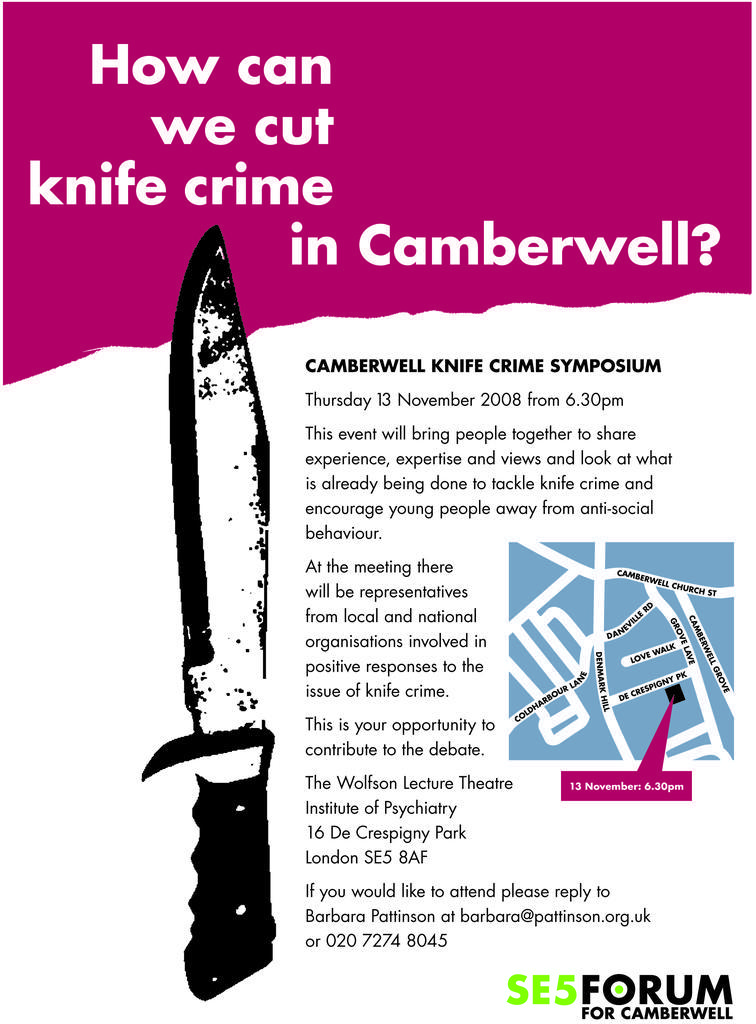In one or two sentences, can you explain what this image depicts? Here we can see a poster. On this poster we can see picture of a knife and text written on it. 